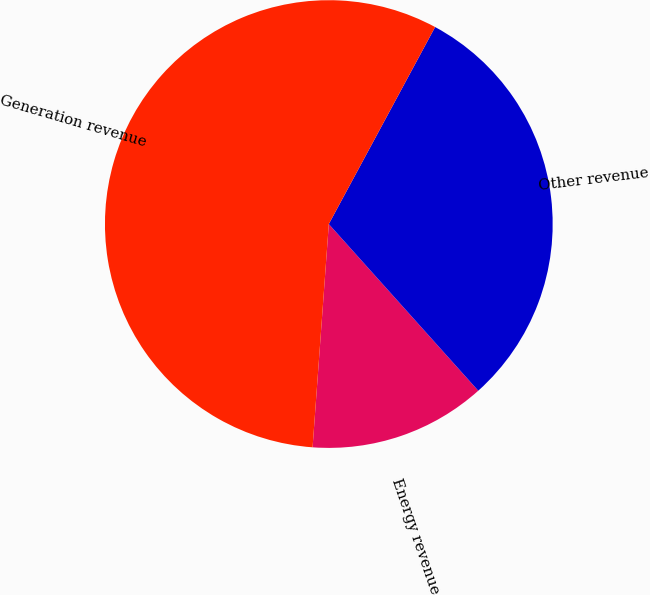Convert chart to OTSL. <chart><loc_0><loc_0><loc_500><loc_500><pie_chart><fcel>Energy revenue<fcel>Other revenue<fcel>Generation revenue<nl><fcel>12.79%<fcel>30.49%<fcel>56.72%<nl></chart> 